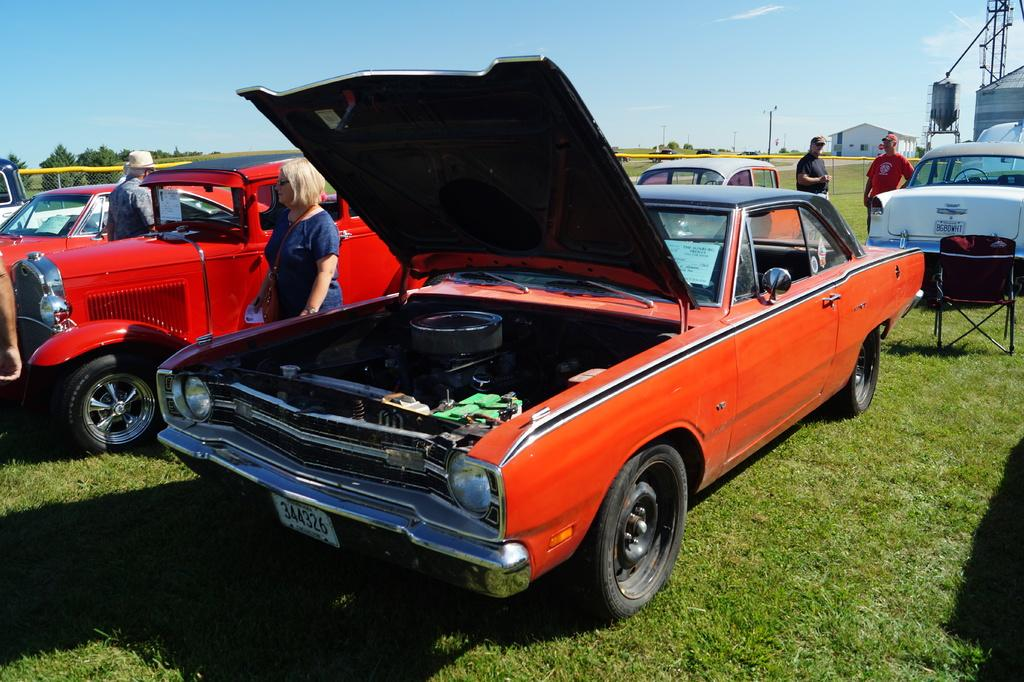What type of vehicles can be seen in the image? There are cars in the image. Who or what else is present in the image? There are people in the image. What can be seen in the background of the image? There are trees and sky visible in the background of the image. What other structures or objects are present in the image? There are poles and a shed in the image. What type of ground surface is visible at the bottom of the image? There is grass at the bottom of the image. Where is the dock located in the image? There is no dock present in the image. What type of field can be seen in the image? There is no field present in the image. 